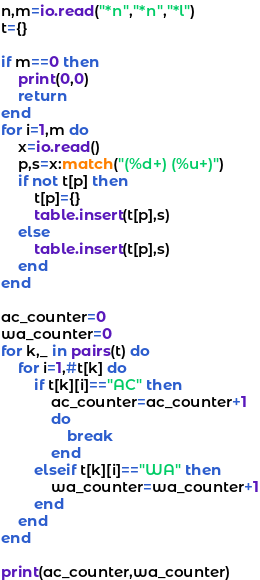<code> <loc_0><loc_0><loc_500><loc_500><_Lua_>n,m=io.read("*n","*n","*l")
t={}

if m==0 then
    print(0,0)
    return
end
for i=1,m do
    x=io.read()
    p,s=x:match("(%d+) (%u+)")
    if not t[p] then
        t[p]={}
        table.insert(t[p],s)
    else
        table.insert(t[p],s)
    end
end

ac_counter=0
wa_counter=0
for k,_ in pairs(t) do
    for i=1,#t[k] do
        if t[k][i]=="AC" then
            ac_counter=ac_counter+1
            do
                break
            end
        elseif t[k][i]=="WA" then
            wa_counter=wa_counter+1
        end
    end
end

print(ac_counter,wa_counter)</code> 